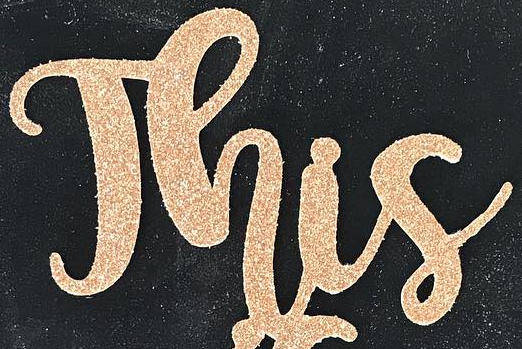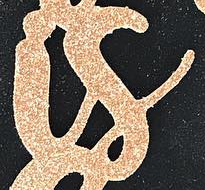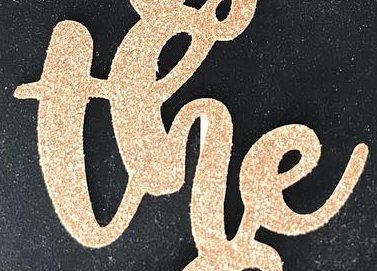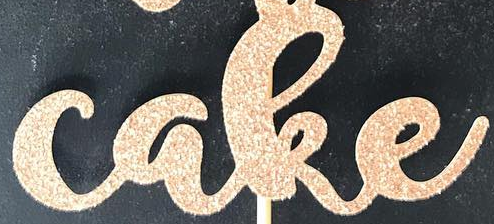Identify the words shown in these images in order, separated by a semicolon. This; is; the; cake 